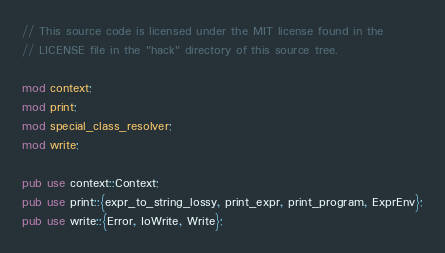Convert code to text. <code><loc_0><loc_0><loc_500><loc_500><_Rust_>// This source code is licensed under the MIT license found in the
// LICENSE file in the "hack" directory of this source tree.

mod context;
mod print;
mod special_class_resolver;
mod write;

pub use context::Context;
pub use print::{expr_to_string_lossy, print_expr, print_program, ExprEnv};
pub use write::{Error, IoWrite, Write};
</code> 